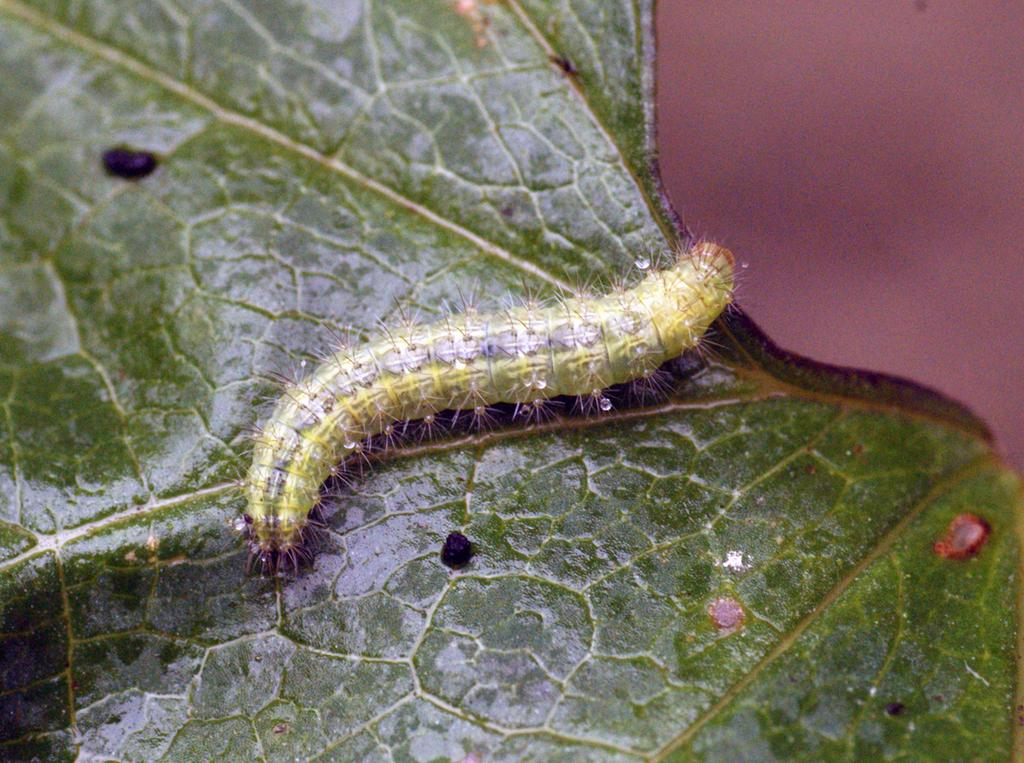What type of animal is in the image? There is a caterpillar in the image. Where is the caterpillar located? The caterpillar is on a leaf. What type of humor can be seen in the image? There is no humor present in the image, as it features a caterpillar on a leaf. What type of clouds are visible in the image? There are no clouds visible in the image, as it only features a caterpillar on a leaf. 